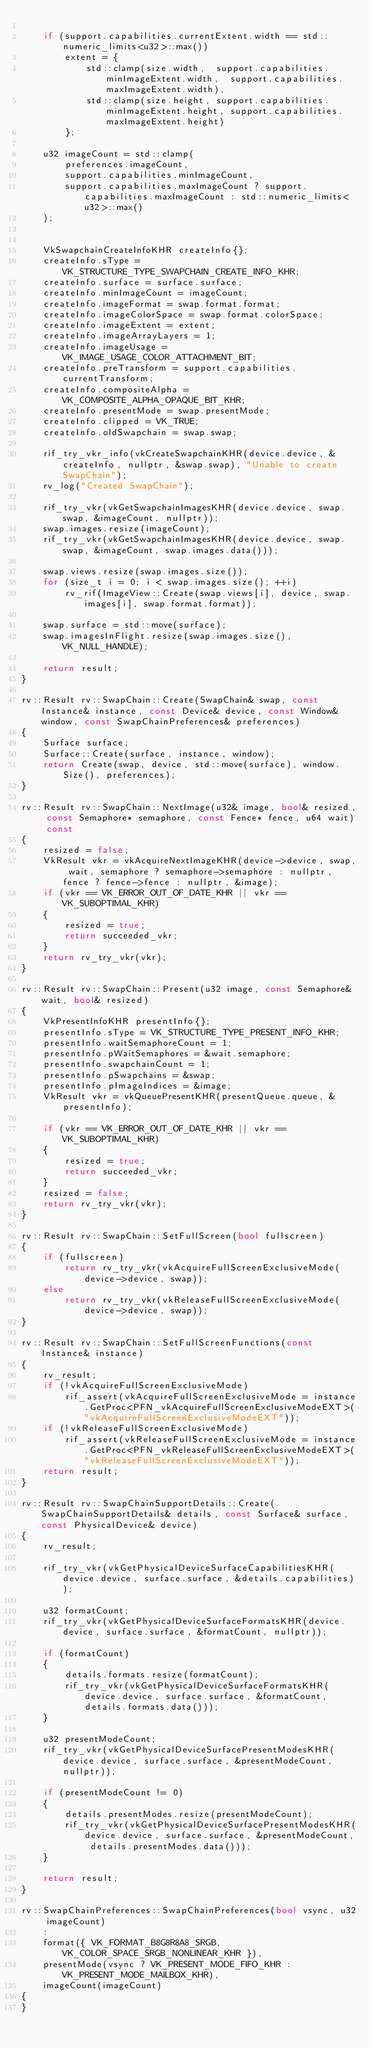Convert code to text. <code><loc_0><loc_0><loc_500><loc_500><_C++_>
	if (support.capabilities.currentExtent.width == std::numeric_limits<u32>::max())
		extent = { 
			std::clamp(size.width,  support.capabilities.minImageExtent.width,  support.capabilities.maxImageExtent.width), 
			std::clamp(size.height, support.capabilities.minImageExtent.height, support.capabilities.maxImageExtent.height)
		};

	u32 imageCount = std::clamp(
		preferences.imageCount, 
		support.capabilities.minImageCount, 
		support.capabilities.maxImageCount ? support.capabilities.maxImageCount : std::numeric_limits<u32>::max()
	);


	VkSwapchainCreateInfoKHR createInfo{};
	createInfo.sType = VK_STRUCTURE_TYPE_SWAPCHAIN_CREATE_INFO_KHR;
	createInfo.surface = surface.surface;
	createInfo.minImageCount = imageCount;
	createInfo.imageFormat = swap.format.format;
	createInfo.imageColorSpace = swap.format.colorSpace;
	createInfo.imageExtent = extent;
	createInfo.imageArrayLayers = 1;
	createInfo.imageUsage = VK_IMAGE_USAGE_COLOR_ATTACHMENT_BIT; 
	createInfo.preTransform = support.capabilities.currentTransform;
	createInfo.compositeAlpha = VK_COMPOSITE_ALPHA_OPAQUE_BIT_KHR;
	createInfo.presentMode = swap.presentMode;
	createInfo.clipped = VK_TRUE;
	createInfo.oldSwapchain = swap.swap;

	rif_try_vkr_info(vkCreateSwapchainKHR(device.device, &createInfo, nullptr, &swap.swap), "Unable to create SwapChain");
	rv_log("Created SwapChain");

	rif_try_vkr(vkGetSwapchainImagesKHR(device.device, swap.swap, &imageCount, nullptr));
	swap.images.resize(imageCount);
	rif_try_vkr(vkGetSwapchainImagesKHR(device.device, swap.swap, &imageCount, swap.images.data()));

	swap.views.resize(swap.images.size());
	for (size_t i = 0; i < swap.images.size(); ++i)
		rv_rif(ImageView::Create(swap.views[i], device, swap.images[i], swap.format.format));

	swap.surface = std::move(surface);
	swap.imagesInFlight.resize(swap.images.size(), VK_NULL_HANDLE);

	return result;
}

rv::Result rv::SwapChain::Create(SwapChain& swap, const Instance& instance, const Device& device, const Window& window, const SwapChainPreferences& preferences)
{
	Surface surface;
	Surface::Create(surface, instance, window);
	return Create(swap, device, std::move(surface), window.Size(), preferences);
}

rv::Result rv::SwapChain::NextImage(u32& image, bool& resized, const Semaphore* semaphore, const Fence* fence, u64 wait) const
{
	resized = false;
	VkResult vkr = vkAcquireNextImageKHR(device->device, swap, wait, semaphore ? semaphore->semaphore : nullptr, fence ? fence->fence : nullptr, &image);
	if (vkr == VK_ERROR_OUT_OF_DATE_KHR || vkr == VK_SUBOPTIMAL_KHR)
	{
		resized = true;
		return succeeded_vkr;
	}
	return rv_try_vkr(vkr);
}

rv::Result rv::SwapChain::Present(u32 image, const Semaphore& wait, bool& resized)
{
	VkPresentInfoKHR presentInfo{};
	presentInfo.sType = VK_STRUCTURE_TYPE_PRESENT_INFO_KHR;
	presentInfo.waitSemaphoreCount = 1;
	presentInfo.pWaitSemaphores = &wait.semaphore;
	presentInfo.swapchainCount = 1;
	presentInfo.pSwapchains = &swap;
	presentInfo.pImageIndices = &image;
	VkResult vkr = vkQueuePresentKHR(presentQueue.queue, &presentInfo);

	if (vkr == VK_ERROR_OUT_OF_DATE_KHR || vkr == VK_SUBOPTIMAL_KHR)
	{
		resized = true;
		return succeeded_vkr;
	}
	resized = false;
	return rv_try_vkr(vkr);
}

rv::Result rv::SwapChain::SetFullScreen(bool fullscreen)
{
	if (fullscreen)
		return rv_try_vkr(vkAcquireFullScreenExclusiveMode(device->device, swap));
	else
		return rv_try_vkr(vkReleaseFullScreenExclusiveMode(device->device, swap));
}

rv::Result rv::SwapChain::SetFullScreenFunctions(const Instance& instance)
{
	rv_result;
	if (!vkAcquireFullScreenExclusiveMode)
		rif_assert(vkAcquireFullScreenExclusiveMode = instance.GetProc<PFN_vkAcquireFullScreenExclusiveModeEXT>("vkAcquireFullScreenExclusiveModeEXT"));
	if (!vkReleaseFullScreenExclusiveMode)
		rif_assert(vkReleaseFullScreenExclusiveMode = instance.GetProc<PFN_vkReleaseFullScreenExclusiveModeEXT>("vkReleaseFullScreenExclusiveModeEXT"));
	return result;
}

rv::Result rv::SwapChainSupportDetails::Create(SwapChainSupportDetails& details, const Surface& surface, const PhysicalDevice& device)
{
	rv_result;

	rif_try_vkr(vkGetPhysicalDeviceSurfaceCapabilitiesKHR(device.device, surface.surface, &details.capabilities));

	u32 formatCount;
	rif_try_vkr(vkGetPhysicalDeviceSurfaceFormatsKHR(device.device, surface.surface, &formatCount, nullptr));

	if (formatCount) 
	{
		details.formats.resize(formatCount);
		rif_try_vkr(vkGetPhysicalDeviceSurfaceFormatsKHR(device.device, surface.surface, &formatCount, details.formats.data()));
	}

	u32 presentModeCount;
	rif_try_vkr(vkGetPhysicalDeviceSurfacePresentModesKHR(device.device, surface.surface, &presentModeCount, nullptr));

	if (presentModeCount != 0) 
	{
		details.presentModes.resize(presentModeCount);
		rif_try_vkr(vkGetPhysicalDeviceSurfacePresentModesKHR(device.device, surface.surface, &presentModeCount, details.presentModes.data()));
	}

	return result;
}

rv::SwapChainPreferences::SwapChainPreferences(bool vsync, u32 imageCount)
	:
	format({ VK_FORMAT_B8G8R8A8_SRGB, VK_COLOR_SPACE_SRGB_NONLINEAR_KHR }),
	presentMode(vsync ? VK_PRESENT_MODE_FIFO_KHR : VK_PRESENT_MODE_MAILBOX_KHR),
	imageCount(imageCount)
{
}
</code> 